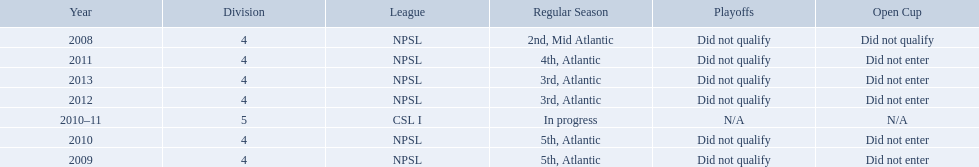What are the names of the leagues? NPSL, CSL I. Which league other than npsl did ny soccer team play under? CSL I. 